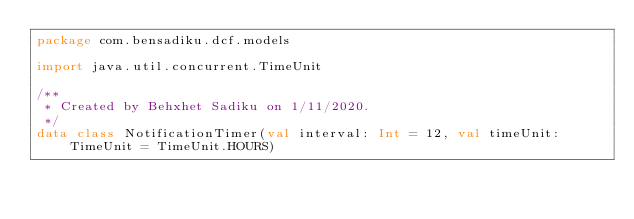<code> <loc_0><loc_0><loc_500><loc_500><_Kotlin_>package com.bensadiku.dcf.models

import java.util.concurrent.TimeUnit

/**
 * Created by Behxhet Sadiku on 1/11/2020.
 */
data class NotificationTimer(val interval: Int = 12, val timeUnit: TimeUnit = TimeUnit.HOURS)</code> 